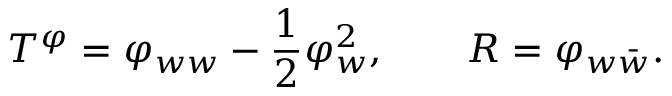Convert formula to latex. <formula><loc_0><loc_0><loc_500><loc_500>T ^ { \varphi } = \varphi _ { w w } - { \frac { 1 } { 2 } } \varphi _ { w } ^ { 2 } , \quad R = \varphi _ { w \bar { w } } .</formula> 